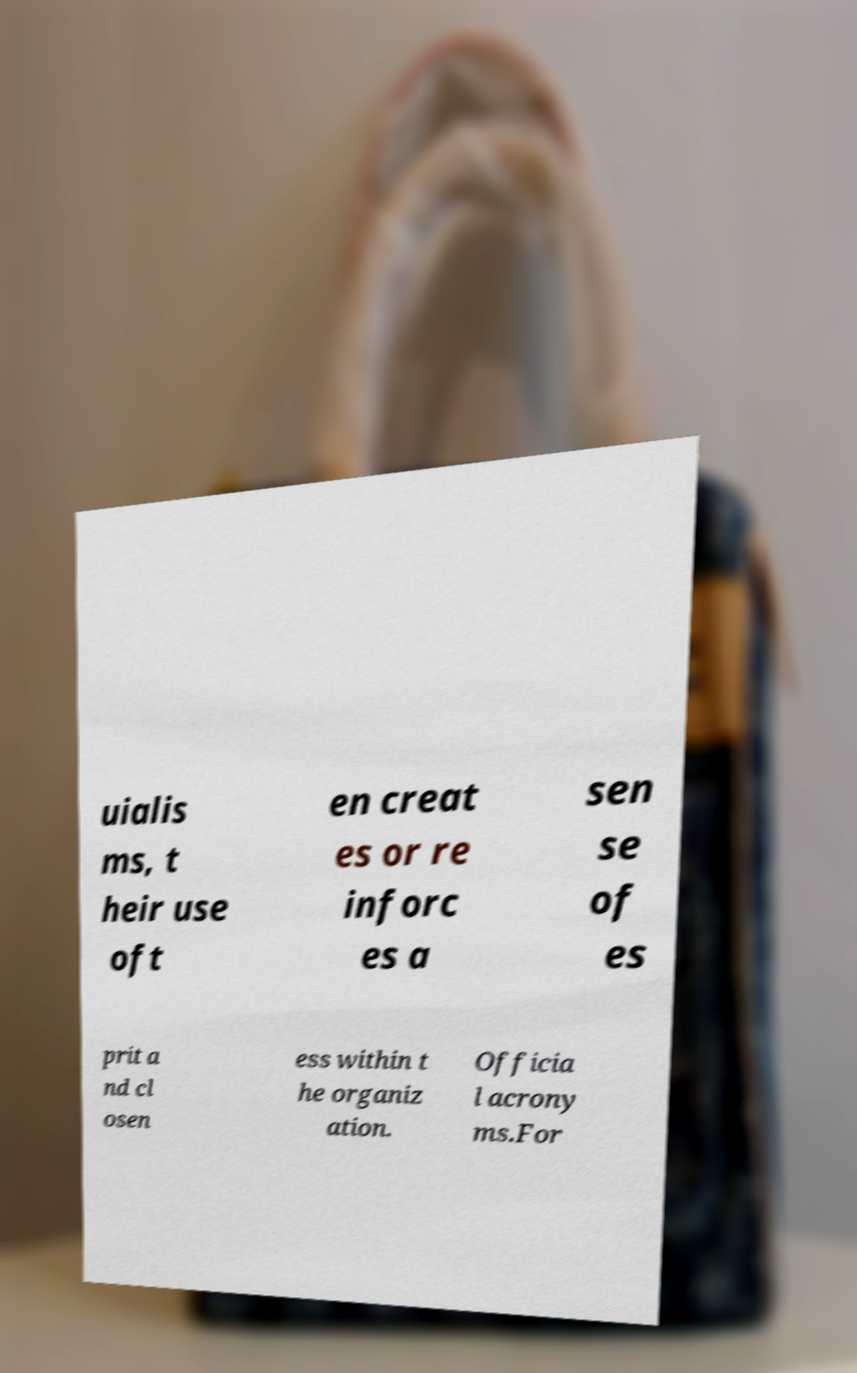There's text embedded in this image that I need extracted. Can you transcribe it verbatim? uialis ms, t heir use oft en creat es or re inforc es a sen se of es prit a nd cl osen ess within t he organiz ation. Officia l acrony ms.For 